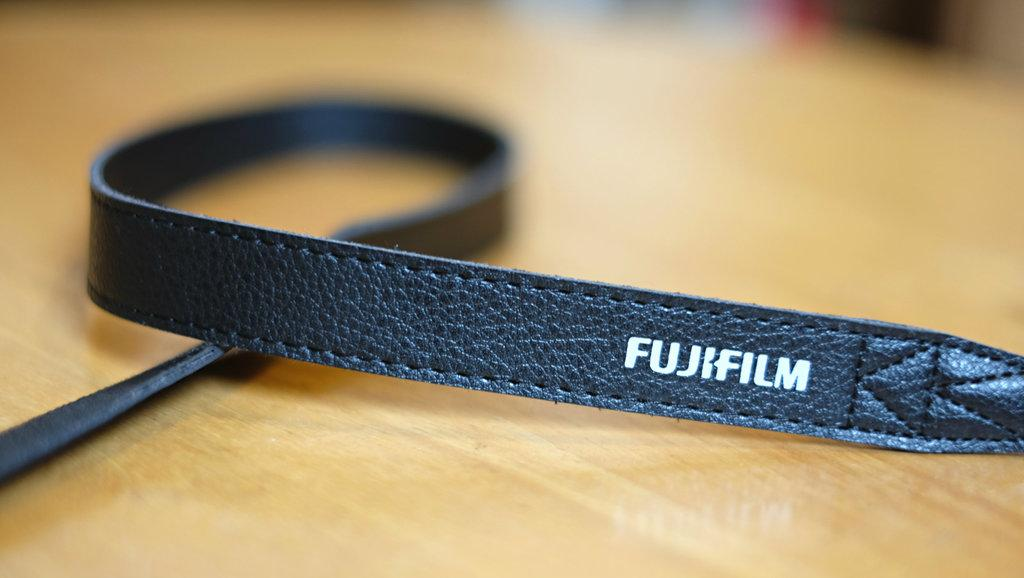What type of object can be seen in the image that is made of leather? There is a leather object with text in the image. Where is the leather object located? The leather object is placed on a table. How many babies are playing a game on the leather object in the image? There are no babies or games present in the image; it features a leather object with text placed on a table. 